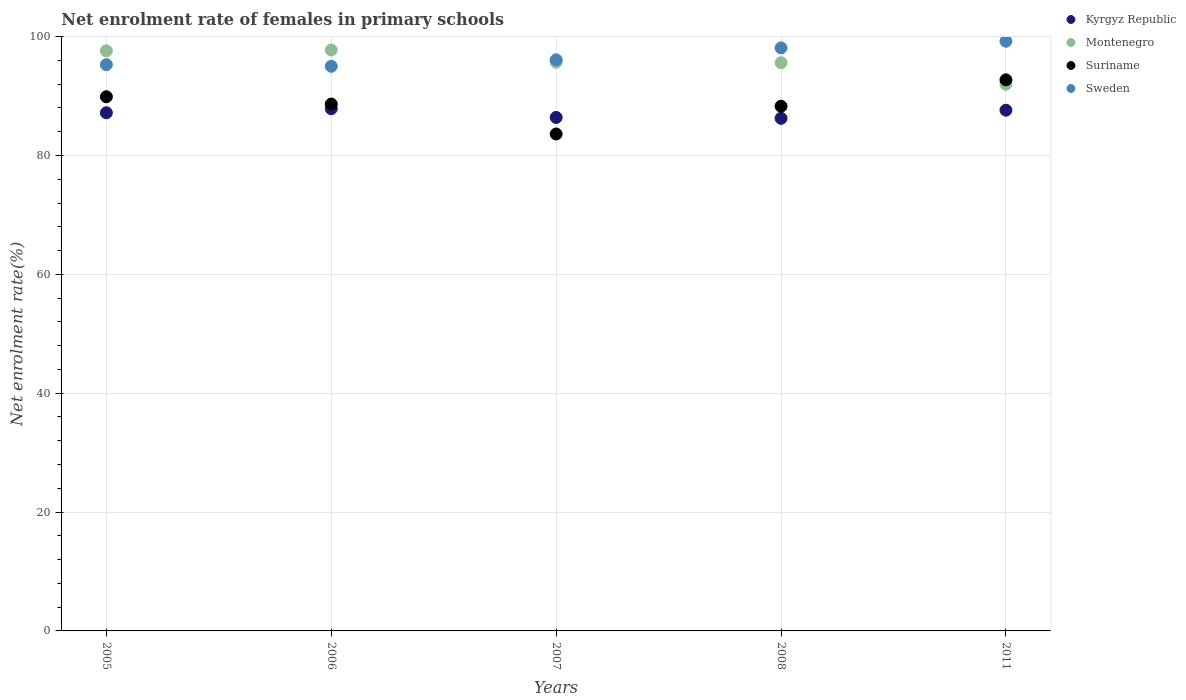Is the number of dotlines equal to the number of legend labels?
Make the answer very short. Yes. What is the net enrolment rate of females in primary schools in Montenegro in 2008?
Offer a very short reply. 95.61. Across all years, what is the maximum net enrolment rate of females in primary schools in Sweden?
Your answer should be compact. 99.23. Across all years, what is the minimum net enrolment rate of females in primary schools in Kyrgyz Republic?
Provide a short and direct response. 86.25. What is the total net enrolment rate of females in primary schools in Montenegro in the graph?
Your answer should be very brief. 478.66. What is the difference between the net enrolment rate of females in primary schools in Montenegro in 2005 and that in 2008?
Provide a succinct answer. 2. What is the difference between the net enrolment rate of females in primary schools in Kyrgyz Republic in 2006 and the net enrolment rate of females in primary schools in Sweden in 2007?
Provide a short and direct response. -8.23. What is the average net enrolment rate of females in primary schools in Suriname per year?
Offer a very short reply. 88.64. In the year 2005, what is the difference between the net enrolment rate of females in primary schools in Kyrgyz Republic and net enrolment rate of females in primary schools in Montenegro?
Offer a terse response. -10.42. In how many years, is the net enrolment rate of females in primary schools in Kyrgyz Republic greater than 8 %?
Keep it short and to the point. 5. What is the ratio of the net enrolment rate of females in primary schools in Suriname in 2007 to that in 2008?
Keep it short and to the point. 0.95. Is the net enrolment rate of females in primary schools in Kyrgyz Republic in 2006 less than that in 2007?
Provide a short and direct response. No. Is the difference between the net enrolment rate of females in primary schools in Kyrgyz Republic in 2005 and 2008 greater than the difference between the net enrolment rate of females in primary schools in Montenegro in 2005 and 2008?
Ensure brevity in your answer.  No. What is the difference between the highest and the second highest net enrolment rate of females in primary schools in Kyrgyz Republic?
Offer a terse response. 0.25. What is the difference between the highest and the lowest net enrolment rate of females in primary schools in Kyrgyz Republic?
Offer a very short reply. 1.62. Is it the case that in every year, the sum of the net enrolment rate of females in primary schools in Kyrgyz Republic and net enrolment rate of females in primary schools in Montenegro  is greater than the sum of net enrolment rate of females in primary schools in Suriname and net enrolment rate of females in primary schools in Sweden?
Ensure brevity in your answer.  No. Is the net enrolment rate of females in primary schools in Suriname strictly greater than the net enrolment rate of females in primary schools in Kyrgyz Republic over the years?
Keep it short and to the point. No. What is the difference between two consecutive major ticks on the Y-axis?
Offer a terse response. 20. Does the graph contain grids?
Make the answer very short. Yes. Where does the legend appear in the graph?
Provide a short and direct response. Top right. How are the legend labels stacked?
Keep it short and to the point. Vertical. What is the title of the graph?
Your response must be concise. Net enrolment rate of females in primary schools. Does "Monaco" appear as one of the legend labels in the graph?
Your answer should be compact. No. What is the label or title of the Y-axis?
Keep it short and to the point. Net enrolment rate(%). What is the Net enrolment rate(%) of Kyrgyz Republic in 2005?
Your answer should be compact. 87.19. What is the Net enrolment rate(%) of Montenegro in 2005?
Your answer should be compact. 97.61. What is the Net enrolment rate(%) of Suriname in 2005?
Your answer should be very brief. 89.89. What is the Net enrolment rate(%) of Sweden in 2005?
Ensure brevity in your answer.  95.28. What is the Net enrolment rate(%) of Kyrgyz Republic in 2006?
Your answer should be compact. 87.87. What is the Net enrolment rate(%) of Montenegro in 2006?
Your response must be concise. 97.76. What is the Net enrolment rate(%) in Suriname in 2006?
Ensure brevity in your answer.  88.66. What is the Net enrolment rate(%) in Sweden in 2006?
Keep it short and to the point. 95.01. What is the Net enrolment rate(%) in Kyrgyz Republic in 2007?
Provide a succinct answer. 86.4. What is the Net enrolment rate(%) in Montenegro in 2007?
Ensure brevity in your answer.  95.69. What is the Net enrolment rate(%) of Suriname in 2007?
Your answer should be very brief. 83.62. What is the Net enrolment rate(%) in Sweden in 2007?
Give a very brief answer. 96.1. What is the Net enrolment rate(%) in Kyrgyz Republic in 2008?
Your answer should be compact. 86.25. What is the Net enrolment rate(%) of Montenegro in 2008?
Offer a very short reply. 95.61. What is the Net enrolment rate(%) of Suriname in 2008?
Your answer should be very brief. 88.29. What is the Net enrolment rate(%) of Sweden in 2008?
Keep it short and to the point. 98.1. What is the Net enrolment rate(%) in Kyrgyz Republic in 2011?
Make the answer very short. 87.62. What is the Net enrolment rate(%) in Montenegro in 2011?
Give a very brief answer. 91.99. What is the Net enrolment rate(%) in Suriname in 2011?
Keep it short and to the point. 92.73. What is the Net enrolment rate(%) of Sweden in 2011?
Ensure brevity in your answer.  99.23. Across all years, what is the maximum Net enrolment rate(%) in Kyrgyz Republic?
Your response must be concise. 87.87. Across all years, what is the maximum Net enrolment rate(%) of Montenegro?
Give a very brief answer. 97.76. Across all years, what is the maximum Net enrolment rate(%) of Suriname?
Your answer should be compact. 92.73. Across all years, what is the maximum Net enrolment rate(%) of Sweden?
Your answer should be compact. 99.23. Across all years, what is the minimum Net enrolment rate(%) in Kyrgyz Republic?
Give a very brief answer. 86.25. Across all years, what is the minimum Net enrolment rate(%) of Montenegro?
Ensure brevity in your answer.  91.99. Across all years, what is the minimum Net enrolment rate(%) in Suriname?
Provide a short and direct response. 83.62. Across all years, what is the minimum Net enrolment rate(%) in Sweden?
Offer a very short reply. 95.01. What is the total Net enrolment rate(%) of Kyrgyz Republic in the graph?
Give a very brief answer. 435.34. What is the total Net enrolment rate(%) in Montenegro in the graph?
Make the answer very short. 478.66. What is the total Net enrolment rate(%) of Suriname in the graph?
Your response must be concise. 443.19. What is the total Net enrolment rate(%) in Sweden in the graph?
Provide a short and direct response. 483.72. What is the difference between the Net enrolment rate(%) of Kyrgyz Republic in 2005 and that in 2006?
Keep it short and to the point. -0.68. What is the difference between the Net enrolment rate(%) of Montenegro in 2005 and that in 2006?
Offer a terse response. -0.14. What is the difference between the Net enrolment rate(%) in Suriname in 2005 and that in 2006?
Your answer should be very brief. 1.22. What is the difference between the Net enrolment rate(%) in Sweden in 2005 and that in 2006?
Provide a succinct answer. 0.27. What is the difference between the Net enrolment rate(%) in Kyrgyz Republic in 2005 and that in 2007?
Provide a short and direct response. 0.79. What is the difference between the Net enrolment rate(%) in Montenegro in 2005 and that in 2007?
Make the answer very short. 1.92. What is the difference between the Net enrolment rate(%) in Suriname in 2005 and that in 2007?
Ensure brevity in your answer.  6.27. What is the difference between the Net enrolment rate(%) of Sweden in 2005 and that in 2007?
Keep it short and to the point. -0.82. What is the difference between the Net enrolment rate(%) in Kyrgyz Republic in 2005 and that in 2008?
Keep it short and to the point. 0.94. What is the difference between the Net enrolment rate(%) of Montenegro in 2005 and that in 2008?
Your answer should be compact. 2. What is the difference between the Net enrolment rate(%) of Suriname in 2005 and that in 2008?
Provide a succinct answer. 1.6. What is the difference between the Net enrolment rate(%) in Sweden in 2005 and that in 2008?
Keep it short and to the point. -2.83. What is the difference between the Net enrolment rate(%) in Kyrgyz Republic in 2005 and that in 2011?
Your answer should be very brief. -0.43. What is the difference between the Net enrolment rate(%) in Montenegro in 2005 and that in 2011?
Keep it short and to the point. 5.62. What is the difference between the Net enrolment rate(%) in Suriname in 2005 and that in 2011?
Your answer should be very brief. -2.84. What is the difference between the Net enrolment rate(%) of Sweden in 2005 and that in 2011?
Provide a short and direct response. -3.95. What is the difference between the Net enrolment rate(%) in Kyrgyz Republic in 2006 and that in 2007?
Offer a terse response. 1.47. What is the difference between the Net enrolment rate(%) of Montenegro in 2006 and that in 2007?
Provide a short and direct response. 2.06. What is the difference between the Net enrolment rate(%) of Suriname in 2006 and that in 2007?
Provide a succinct answer. 5.04. What is the difference between the Net enrolment rate(%) in Sweden in 2006 and that in 2007?
Offer a terse response. -1.09. What is the difference between the Net enrolment rate(%) in Kyrgyz Republic in 2006 and that in 2008?
Provide a short and direct response. 1.62. What is the difference between the Net enrolment rate(%) of Montenegro in 2006 and that in 2008?
Provide a short and direct response. 2.15. What is the difference between the Net enrolment rate(%) of Suriname in 2006 and that in 2008?
Keep it short and to the point. 0.37. What is the difference between the Net enrolment rate(%) in Sweden in 2006 and that in 2008?
Give a very brief answer. -3.09. What is the difference between the Net enrolment rate(%) in Kyrgyz Republic in 2006 and that in 2011?
Ensure brevity in your answer.  0.25. What is the difference between the Net enrolment rate(%) of Montenegro in 2006 and that in 2011?
Offer a terse response. 5.77. What is the difference between the Net enrolment rate(%) in Suriname in 2006 and that in 2011?
Keep it short and to the point. -4.07. What is the difference between the Net enrolment rate(%) of Sweden in 2006 and that in 2011?
Give a very brief answer. -4.22. What is the difference between the Net enrolment rate(%) of Kyrgyz Republic in 2007 and that in 2008?
Your answer should be compact. 0.15. What is the difference between the Net enrolment rate(%) of Montenegro in 2007 and that in 2008?
Your answer should be very brief. 0.08. What is the difference between the Net enrolment rate(%) of Suriname in 2007 and that in 2008?
Ensure brevity in your answer.  -4.67. What is the difference between the Net enrolment rate(%) in Sweden in 2007 and that in 2008?
Provide a short and direct response. -2.01. What is the difference between the Net enrolment rate(%) in Kyrgyz Republic in 2007 and that in 2011?
Your answer should be compact. -1.22. What is the difference between the Net enrolment rate(%) in Montenegro in 2007 and that in 2011?
Ensure brevity in your answer.  3.7. What is the difference between the Net enrolment rate(%) of Suriname in 2007 and that in 2011?
Your response must be concise. -9.11. What is the difference between the Net enrolment rate(%) of Sweden in 2007 and that in 2011?
Keep it short and to the point. -3.13. What is the difference between the Net enrolment rate(%) in Kyrgyz Republic in 2008 and that in 2011?
Your answer should be compact. -1.37. What is the difference between the Net enrolment rate(%) of Montenegro in 2008 and that in 2011?
Offer a terse response. 3.62. What is the difference between the Net enrolment rate(%) in Suriname in 2008 and that in 2011?
Make the answer very short. -4.44. What is the difference between the Net enrolment rate(%) in Sweden in 2008 and that in 2011?
Make the answer very short. -1.13. What is the difference between the Net enrolment rate(%) of Kyrgyz Republic in 2005 and the Net enrolment rate(%) of Montenegro in 2006?
Provide a succinct answer. -10.56. What is the difference between the Net enrolment rate(%) in Kyrgyz Republic in 2005 and the Net enrolment rate(%) in Suriname in 2006?
Ensure brevity in your answer.  -1.47. What is the difference between the Net enrolment rate(%) of Kyrgyz Republic in 2005 and the Net enrolment rate(%) of Sweden in 2006?
Offer a very short reply. -7.82. What is the difference between the Net enrolment rate(%) in Montenegro in 2005 and the Net enrolment rate(%) in Suriname in 2006?
Your response must be concise. 8.95. What is the difference between the Net enrolment rate(%) in Montenegro in 2005 and the Net enrolment rate(%) in Sweden in 2006?
Your response must be concise. 2.6. What is the difference between the Net enrolment rate(%) in Suriname in 2005 and the Net enrolment rate(%) in Sweden in 2006?
Your response must be concise. -5.12. What is the difference between the Net enrolment rate(%) of Kyrgyz Republic in 2005 and the Net enrolment rate(%) of Montenegro in 2007?
Make the answer very short. -8.5. What is the difference between the Net enrolment rate(%) of Kyrgyz Republic in 2005 and the Net enrolment rate(%) of Suriname in 2007?
Your response must be concise. 3.57. What is the difference between the Net enrolment rate(%) in Kyrgyz Republic in 2005 and the Net enrolment rate(%) in Sweden in 2007?
Your response must be concise. -8.91. What is the difference between the Net enrolment rate(%) in Montenegro in 2005 and the Net enrolment rate(%) in Suriname in 2007?
Keep it short and to the point. 13.99. What is the difference between the Net enrolment rate(%) in Montenegro in 2005 and the Net enrolment rate(%) in Sweden in 2007?
Your answer should be very brief. 1.52. What is the difference between the Net enrolment rate(%) of Suriname in 2005 and the Net enrolment rate(%) of Sweden in 2007?
Provide a succinct answer. -6.21. What is the difference between the Net enrolment rate(%) in Kyrgyz Republic in 2005 and the Net enrolment rate(%) in Montenegro in 2008?
Keep it short and to the point. -8.42. What is the difference between the Net enrolment rate(%) of Kyrgyz Republic in 2005 and the Net enrolment rate(%) of Suriname in 2008?
Keep it short and to the point. -1.1. What is the difference between the Net enrolment rate(%) of Kyrgyz Republic in 2005 and the Net enrolment rate(%) of Sweden in 2008?
Give a very brief answer. -10.91. What is the difference between the Net enrolment rate(%) in Montenegro in 2005 and the Net enrolment rate(%) in Suriname in 2008?
Offer a terse response. 9.32. What is the difference between the Net enrolment rate(%) of Montenegro in 2005 and the Net enrolment rate(%) of Sweden in 2008?
Give a very brief answer. -0.49. What is the difference between the Net enrolment rate(%) of Suriname in 2005 and the Net enrolment rate(%) of Sweden in 2008?
Ensure brevity in your answer.  -8.22. What is the difference between the Net enrolment rate(%) of Kyrgyz Republic in 2005 and the Net enrolment rate(%) of Montenegro in 2011?
Provide a succinct answer. -4.8. What is the difference between the Net enrolment rate(%) of Kyrgyz Republic in 2005 and the Net enrolment rate(%) of Suriname in 2011?
Offer a very short reply. -5.54. What is the difference between the Net enrolment rate(%) in Kyrgyz Republic in 2005 and the Net enrolment rate(%) in Sweden in 2011?
Your answer should be very brief. -12.04. What is the difference between the Net enrolment rate(%) in Montenegro in 2005 and the Net enrolment rate(%) in Suriname in 2011?
Your answer should be compact. 4.88. What is the difference between the Net enrolment rate(%) of Montenegro in 2005 and the Net enrolment rate(%) of Sweden in 2011?
Ensure brevity in your answer.  -1.62. What is the difference between the Net enrolment rate(%) in Suriname in 2005 and the Net enrolment rate(%) in Sweden in 2011?
Offer a terse response. -9.34. What is the difference between the Net enrolment rate(%) of Kyrgyz Republic in 2006 and the Net enrolment rate(%) of Montenegro in 2007?
Make the answer very short. -7.82. What is the difference between the Net enrolment rate(%) of Kyrgyz Republic in 2006 and the Net enrolment rate(%) of Suriname in 2007?
Your answer should be very brief. 4.25. What is the difference between the Net enrolment rate(%) in Kyrgyz Republic in 2006 and the Net enrolment rate(%) in Sweden in 2007?
Make the answer very short. -8.23. What is the difference between the Net enrolment rate(%) in Montenegro in 2006 and the Net enrolment rate(%) in Suriname in 2007?
Your response must be concise. 14.14. What is the difference between the Net enrolment rate(%) in Montenegro in 2006 and the Net enrolment rate(%) in Sweden in 2007?
Your answer should be compact. 1.66. What is the difference between the Net enrolment rate(%) in Suriname in 2006 and the Net enrolment rate(%) in Sweden in 2007?
Provide a short and direct response. -7.43. What is the difference between the Net enrolment rate(%) of Kyrgyz Republic in 2006 and the Net enrolment rate(%) of Montenegro in 2008?
Provide a succinct answer. -7.74. What is the difference between the Net enrolment rate(%) of Kyrgyz Republic in 2006 and the Net enrolment rate(%) of Suriname in 2008?
Give a very brief answer. -0.42. What is the difference between the Net enrolment rate(%) in Kyrgyz Republic in 2006 and the Net enrolment rate(%) in Sweden in 2008?
Keep it short and to the point. -10.24. What is the difference between the Net enrolment rate(%) in Montenegro in 2006 and the Net enrolment rate(%) in Suriname in 2008?
Ensure brevity in your answer.  9.47. What is the difference between the Net enrolment rate(%) of Montenegro in 2006 and the Net enrolment rate(%) of Sweden in 2008?
Make the answer very short. -0.35. What is the difference between the Net enrolment rate(%) in Suriname in 2006 and the Net enrolment rate(%) in Sweden in 2008?
Provide a succinct answer. -9.44. What is the difference between the Net enrolment rate(%) in Kyrgyz Republic in 2006 and the Net enrolment rate(%) in Montenegro in 2011?
Give a very brief answer. -4.12. What is the difference between the Net enrolment rate(%) in Kyrgyz Republic in 2006 and the Net enrolment rate(%) in Suriname in 2011?
Your answer should be very brief. -4.86. What is the difference between the Net enrolment rate(%) of Kyrgyz Republic in 2006 and the Net enrolment rate(%) of Sweden in 2011?
Your response must be concise. -11.36. What is the difference between the Net enrolment rate(%) in Montenegro in 2006 and the Net enrolment rate(%) in Suriname in 2011?
Your answer should be very brief. 5.02. What is the difference between the Net enrolment rate(%) in Montenegro in 2006 and the Net enrolment rate(%) in Sweden in 2011?
Provide a succinct answer. -1.48. What is the difference between the Net enrolment rate(%) in Suriname in 2006 and the Net enrolment rate(%) in Sweden in 2011?
Give a very brief answer. -10.57. What is the difference between the Net enrolment rate(%) of Kyrgyz Republic in 2007 and the Net enrolment rate(%) of Montenegro in 2008?
Your response must be concise. -9.21. What is the difference between the Net enrolment rate(%) of Kyrgyz Republic in 2007 and the Net enrolment rate(%) of Suriname in 2008?
Your answer should be compact. -1.89. What is the difference between the Net enrolment rate(%) of Kyrgyz Republic in 2007 and the Net enrolment rate(%) of Sweden in 2008?
Offer a very short reply. -11.7. What is the difference between the Net enrolment rate(%) in Montenegro in 2007 and the Net enrolment rate(%) in Suriname in 2008?
Ensure brevity in your answer.  7.4. What is the difference between the Net enrolment rate(%) in Montenegro in 2007 and the Net enrolment rate(%) in Sweden in 2008?
Offer a terse response. -2.41. What is the difference between the Net enrolment rate(%) in Suriname in 2007 and the Net enrolment rate(%) in Sweden in 2008?
Offer a terse response. -14.48. What is the difference between the Net enrolment rate(%) of Kyrgyz Republic in 2007 and the Net enrolment rate(%) of Montenegro in 2011?
Your answer should be very brief. -5.59. What is the difference between the Net enrolment rate(%) in Kyrgyz Republic in 2007 and the Net enrolment rate(%) in Suriname in 2011?
Offer a terse response. -6.33. What is the difference between the Net enrolment rate(%) in Kyrgyz Republic in 2007 and the Net enrolment rate(%) in Sweden in 2011?
Provide a short and direct response. -12.83. What is the difference between the Net enrolment rate(%) of Montenegro in 2007 and the Net enrolment rate(%) of Suriname in 2011?
Keep it short and to the point. 2.96. What is the difference between the Net enrolment rate(%) of Montenegro in 2007 and the Net enrolment rate(%) of Sweden in 2011?
Ensure brevity in your answer.  -3.54. What is the difference between the Net enrolment rate(%) of Suriname in 2007 and the Net enrolment rate(%) of Sweden in 2011?
Offer a terse response. -15.61. What is the difference between the Net enrolment rate(%) in Kyrgyz Republic in 2008 and the Net enrolment rate(%) in Montenegro in 2011?
Your answer should be very brief. -5.74. What is the difference between the Net enrolment rate(%) in Kyrgyz Republic in 2008 and the Net enrolment rate(%) in Suriname in 2011?
Keep it short and to the point. -6.48. What is the difference between the Net enrolment rate(%) in Kyrgyz Republic in 2008 and the Net enrolment rate(%) in Sweden in 2011?
Keep it short and to the point. -12.98. What is the difference between the Net enrolment rate(%) in Montenegro in 2008 and the Net enrolment rate(%) in Suriname in 2011?
Provide a short and direct response. 2.88. What is the difference between the Net enrolment rate(%) in Montenegro in 2008 and the Net enrolment rate(%) in Sweden in 2011?
Give a very brief answer. -3.62. What is the difference between the Net enrolment rate(%) of Suriname in 2008 and the Net enrolment rate(%) of Sweden in 2011?
Ensure brevity in your answer.  -10.94. What is the average Net enrolment rate(%) in Kyrgyz Republic per year?
Provide a short and direct response. 87.07. What is the average Net enrolment rate(%) in Montenegro per year?
Offer a terse response. 95.73. What is the average Net enrolment rate(%) of Suriname per year?
Give a very brief answer. 88.64. What is the average Net enrolment rate(%) in Sweden per year?
Ensure brevity in your answer.  96.74. In the year 2005, what is the difference between the Net enrolment rate(%) in Kyrgyz Republic and Net enrolment rate(%) in Montenegro?
Offer a very short reply. -10.42. In the year 2005, what is the difference between the Net enrolment rate(%) of Kyrgyz Republic and Net enrolment rate(%) of Suriname?
Offer a very short reply. -2.7. In the year 2005, what is the difference between the Net enrolment rate(%) of Kyrgyz Republic and Net enrolment rate(%) of Sweden?
Provide a short and direct response. -8.09. In the year 2005, what is the difference between the Net enrolment rate(%) of Montenegro and Net enrolment rate(%) of Suriname?
Offer a terse response. 7.73. In the year 2005, what is the difference between the Net enrolment rate(%) in Montenegro and Net enrolment rate(%) in Sweden?
Your answer should be compact. 2.33. In the year 2005, what is the difference between the Net enrolment rate(%) in Suriname and Net enrolment rate(%) in Sweden?
Provide a succinct answer. -5.39. In the year 2006, what is the difference between the Net enrolment rate(%) in Kyrgyz Republic and Net enrolment rate(%) in Montenegro?
Provide a succinct answer. -9.89. In the year 2006, what is the difference between the Net enrolment rate(%) of Kyrgyz Republic and Net enrolment rate(%) of Suriname?
Keep it short and to the point. -0.79. In the year 2006, what is the difference between the Net enrolment rate(%) in Kyrgyz Republic and Net enrolment rate(%) in Sweden?
Provide a short and direct response. -7.14. In the year 2006, what is the difference between the Net enrolment rate(%) in Montenegro and Net enrolment rate(%) in Suriname?
Your answer should be compact. 9.09. In the year 2006, what is the difference between the Net enrolment rate(%) in Montenegro and Net enrolment rate(%) in Sweden?
Provide a short and direct response. 2.74. In the year 2006, what is the difference between the Net enrolment rate(%) of Suriname and Net enrolment rate(%) of Sweden?
Your response must be concise. -6.35. In the year 2007, what is the difference between the Net enrolment rate(%) of Kyrgyz Republic and Net enrolment rate(%) of Montenegro?
Keep it short and to the point. -9.29. In the year 2007, what is the difference between the Net enrolment rate(%) of Kyrgyz Republic and Net enrolment rate(%) of Suriname?
Give a very brief answer. 2.78. In the year 2007, what is the difference between the Net enrolment rate(%) in Kyrgyz Republic and Net enrolment rate(%) in Sweden?
Offer a very short reply. -9.7. In the year 2007, what is the difference between the Net enrolment rate(%) in Montenegro and Net enrolment rate(%) in Suriname?
Your answer should be compact. 12.07. In the year 2007, what is the difference between the Net enrolment rate(%) of Montenegro and Net enrolment rate(%) of Sweden?
Your answer should be very brief. -0.41. In the year 2007, what is the difference between the Net enrolment rate(%) in Suriname and Net enrolment rate(%) in Sweden?
Ensure brevity in your answer.  -12.48. In the year 2008, what is the difference between the Net enrolment rate(%) in Kyrgyz Republic and Net enrolment rate(%) in Montenegro?
Provide a short and direct response. -9.36. In the year 2008, what is the difference between the Net enrolment rate(%) in Kyrgyz Republic and Net enrolment rate(%) in Suriname?
Give a very brief answer. -2.03. In the year 2008, what is the difference between the Net enrolment rate(%) in Kyrgyz Republic and Net enrolment rate(%) in Sweden?
Offer a very short reply. -11.85. In the year 2008, what is the difference between the Net enrolment rate(%) of Montenegro and Net enrolment rate(%) of Suriname?
Your response must be concise. 7.32. In the year 2008, what is the difference between the Net enrolment rate(%) of Montenegro and Net enrolment rate(%) of Sweden?
Make the answer very short. -2.5. In the year 2008, what is the difference between the Net enrolment rate(%) in Suriname and Net enrolment rate(%) in Sweden?
Make the answer very short. -9.82. In the year 2011, what is the difference between the Net enrolment rate(%) in Kyrgyz Republic and Net enrolment rate(%) in Montenegro?
Your answer should be very brief. -4.37. In the year 2011, what is the difference between the Net enrolment rate(%) of Kyrgyz Republic and Net enrolment rate(%) of Suriname?
Give a very brief answer. -5.11. In the year 2011, what is the difference between the Net enrolment rate(%) in Kyrgyz Republic and Net enrolment rate(%) in Sweden?
Give a very brief answer. -11.61. In the year 2011, what is the difference between the Net enrolment rate(%) in Montenegro and Net enrolment rate(%) in Suriname?
Your response must be concise. -0.74. In the year 2011, what is the difference between the Net enrolment rate(%) in Montenegro and Net enrolment rate(%) in Sweden?
Keep it short and to the point. -7.24. In the year 2011, what is the difference between the Net enrolment rate(%) of Suriname and Net enrolment rate(%) of Sweden?
Offer a very short reply. -6.5. What is the ratio of the Net enrolment rate(%) in Kyrgyz Republic in 2005 to that in 2006?
Ensure brevity in your answer.  0.99. What is the ratio of the Net enrolment rate(%) of Suriname in 2005 to that in 2006?
Keep it short and to the point. 1.01. What is the ratio of the Net enrolment rate(%) of Sweden in 2005 to that in 2006?
Give a very brief answer. 1. What is the ratio of the Net enrolment rate(%) of Kyrgyz Republic in 2005 to that in 2007?
Offer a terse response. 1.01. What is the ratio of the Net enrolment rate(%) in Montenegro in 2005 to that in 2007?
Make the answer very short. 1.02. What is the ratio of the Net enrolment rate(%) of Suriname in 2005 to that in 2007?
Offer a very short reply. 1.07. What is the ratio of the Net enrolment rate(%) of Sweden in 2005 to that in 2007?
Offer a very short reply. 0.99. What is the ratio of the Net enrolment rate(%) of Kyrgyz Republic in 2005 to that in 2008?
Offer a very short reply. 1.01. What is the ratio of the Net enrolment rate(%) in Suriname in 2005 to that in 2008?
Offer a terse response. 1.02. What is the ratio of the Net enrolment rate(%) in Sweden in 2005 to that in 2008?
Provide a short and direct response. 0.97. What is the ratio of the Net enrolment rate(%) of Kyrgyz Republic in 2005 to that in 2011?
Offer a terse response. 1. What is the ratio of the Net enrolment rate(%) of Montenegro in 2005 to that in 2011?
Provide a short and direct response. 1.06. What is the ratio of the Net enrolment rate(%) of Suriname in 2005 to that in 2011?
Make the answer very short. 0.97. What is the ratio of the Net enrolment rate(%) of Sweden in 2005 to that in 2011?
Offer a terse response. 0.96. What is the ratio of the Net enrolment rate(%) in Kyrgyz Republic in 2006 to that in 2007?
Your answer should be compact. 1.02. What is the ratio of the Net enrolment rate(%) of Montenegro in 2006 to that in 2007?
Offer a terse response. 1.02. What is the ratio of the Net enrolment rate(%) of Suriname in 2006 to that in 2007?
Offer a very short reply. 1.06. What is the ratio of the Net enrolment rate(%) in Sweden in 2006 to that in 2007?
Ensure brevity in your answer.  0.99. What is the ratio of the Net enrolment rate(%) in Kyrgyz Republic in 2006 to that in 2008?
Offer a terse response. 1.02. What is the ratio of the Net enrolment rate(%) of Montenegro in 2006 to that in 2008?
Make the answer very short. 1.02. What is the ratio of the Net enrolment rate(%) in Suriname in 2006 to that in 2008?
Make the answer very short. 1. What is the ratio of the Net enrolment rate(%) in Sweden in 2006 to that in 2008?
Provide a succinct answer. 0.97. What is the ratio of the Net enrolment rate(%) of Montenegro in 2006 to that in 2011?
Provide a succinct answer. 1.06. What is the ratio of the Net enrolment rate(%) of Suriname in 2006 to that in 2011?
Ensure brevity in your answer.  0.96. What is the ratio of the Net enrolment rate(%) in Sweden in 2006 to that in 2011?
Keep it short and to the point. 0.96. What is the ratio of the Net enrolment rate(%) in Kyrgyz Republic in 2007 to that in 2008?
Offer a terse response. 1. What is the ratio of the Net enrolment rate(%) of Suriname in 2007 to that in 2008?
Make the answer very short. 0.95. What is the ratio of the Net enrolment rate(%) of Sweden in 2007 to that in 2008?
Your response must be concise. 0.98. What is the ratio of the Net enrolment rate(%) in Kyrgyz Republic in 2007 to that in 2011?
Your answer should be very brief. 0.99. What is the ratio of the Net enrolment rate(%) in Montenegro in 2007 to that in 2011?
Your answer should be compact. 1.04. What is the ratio of the Net enrolment rate(%) in Suriname in 2007 to that in 2011?
Your answer should be compact. 0.9. What is the ratio of the Net enrolment rate(%) in Sweden in 2007 to that in 2011?
Offer a very short reply. 0.97. What is the ratio of the Net enrolment rate(%) in Kyrgyz Republic in 2008 to that in 2011?
Provide a short and direct response. 0.98. What is the ratio of the Net enrolment rate(%) in Montenegro in 2008 to that in 2011?
Give a very brief answer. 1.04. What is the ratio of the Net enrolment rate(%) in Suriname in 2008 to that in 2011?
Your response must be concise. 0.95. What is the difference between the highest and the second highest Net enrolment rate(%) in Kyrgyz Republic?
Provide a short and direct response. 0.25. What is the difference between the highest and the second highest Net enrolment rate(%) of Montenegro?
Your answer should be compact. 0.14. What is the difference between the highest and the second highest Net enrolment rate(%) of Suriname?
Make the answer very short. 2.84. What is the difference between the highest and the second highest Net enrolment rate(%) in Sweden?
Keep it short and to the point. 1.13. What is the difference between the highest and the lowest Net enrolment rate(%) of Kyrgyz Republic?
Offer a terse response. 1.62. What is the difference between the highest and the lowest Net enrolment rate(%) of Montenegro?
Your answer should be very brief. 5.77. What is the difference between the highest and the lowest Net enrolment rate(%) of Suriname?
Offer a very short reply. 9.11. What is the difference between the highest and the lowest Net enrolment rate(%) in Sweden?
Provide a succinct answer. 4.22. 